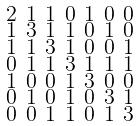<formula> <loc_0><loc_0><loc_500><loc_500>\begin{smallmatrix} 2 & 1 & 1 & 0 & 1 & 0 & 0 \\ 1 & 3 & 1 & 1 & 0 & 1 & 0 \\ 1 & 1 & 3 & 1 & 0 & 0 & 1 \\ 0 & 1 & 1 & 3 & 1 & 1 & 1 \\ 1 & 0 & 0 & 1 & 3 & 0 & 0 \\ 0 & 1 & 0 & 1 & 0 & 3 & 1 \\ 0 & 0 & 1 & 1 & 0 & 1 & 3 \end{smallmatrix}</formula> 